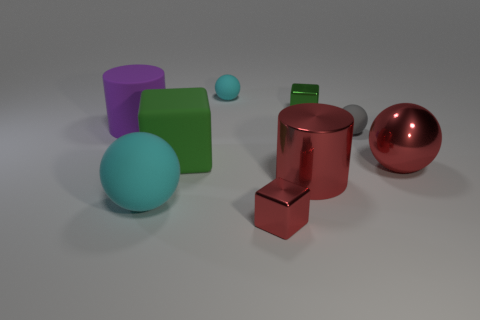Subtract 2 balls. How many balls are left? 2 Subtract all metallic balls. How many balls are left? 3 Subtract all brown cylinders. Subtract all purple blocks. How many cylinders are left? 2 Subtract all cubes. How many objects are left? 6 Subtract all large things. Subtract all red shiny things. How many objects are left? 1 Add 1 big green cubes. How many big green cubes are left? 2 Add 3 tiny objects. How many tiny objects exist? 7 Subtract 2 cyan balls. How many objects are left? 7 